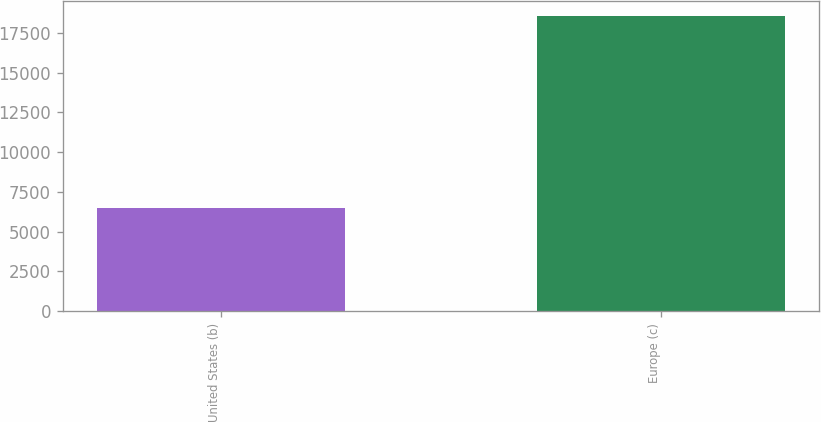Convert chart to OTSL. <chart><loc_0><loc_0><loc_500><loc_500><bar_chart><fcel>United States (b)<fcel>Europe (c)<nl><fcel>6468<fcel>18571<nl></chart> 